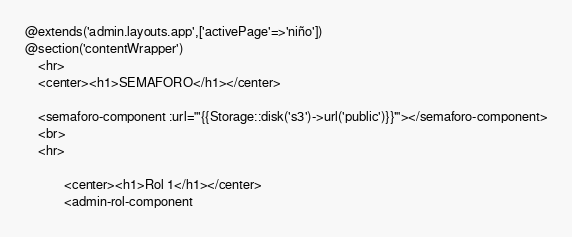<code> <loc_0><loc_0><loc_500><loc_500><_PHP_>@extends('admin.layouts.app',['activePage'=>'niño'])
@section('contentWrapper')
    <hr>
    <center><h1>SEMAFORO</h1></center>

    <semaforo-component :url="'{{Storage::disk('s3')->url('public')}}'"></semaforo-component>
    <br>
    <hr>

            <center><h1>Rol 1</h1></center>
            <admin-rol-component</code> 